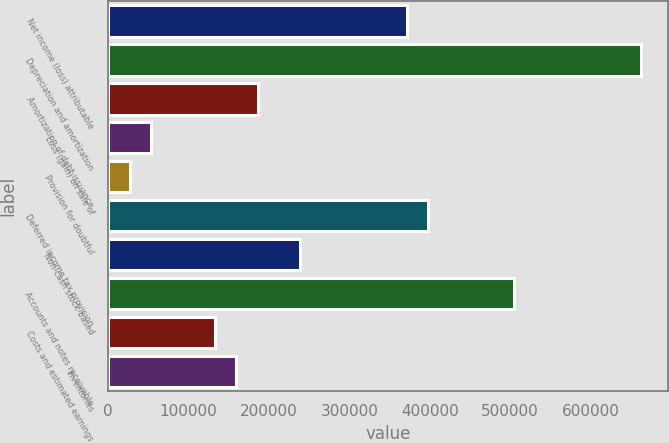Convert chart. <chart><loc_0><loc_0><loc_500><loc_500><bar_chart><fcel>Net income (loss) attributable<fcel>Depreciation and amortization<fcel>Amortization of debt issuance<fcel>Loss (gain) on sale of<fcel>Provision for doubtful<fcel>Deferred income tax provision<fcel>Non-cash stock-based<fcel>Accounts and notes receivable<fcel>Costs and estimated earnings<fcel>Inventories<nl><fcel>371716<fcel>663645<fcel>185943<fcel>53248<fcel>26709<fcel>398255<fcel>239021<fcel>504411<fcel>132865<fcel>159404<nl></chart> 